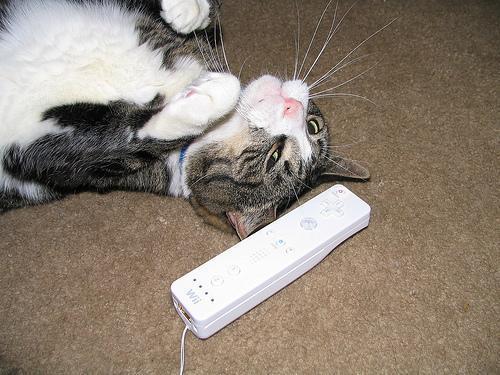How many cats are in the picture?
Give a very brief answer. 1. 